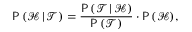Convert formula to latex. <formula><loc_0><loc_0><loc_500><loc_500>P \, ( \mathcal { H } \, | \, \mathcal { T } ) = \frac { P \, ( \mathcal { T } \, | \, \mathcal { H } ) } { P \, ( \mathcal { T } ) } \cdot P \, ( \mathcal { H } ) ,</formula> 